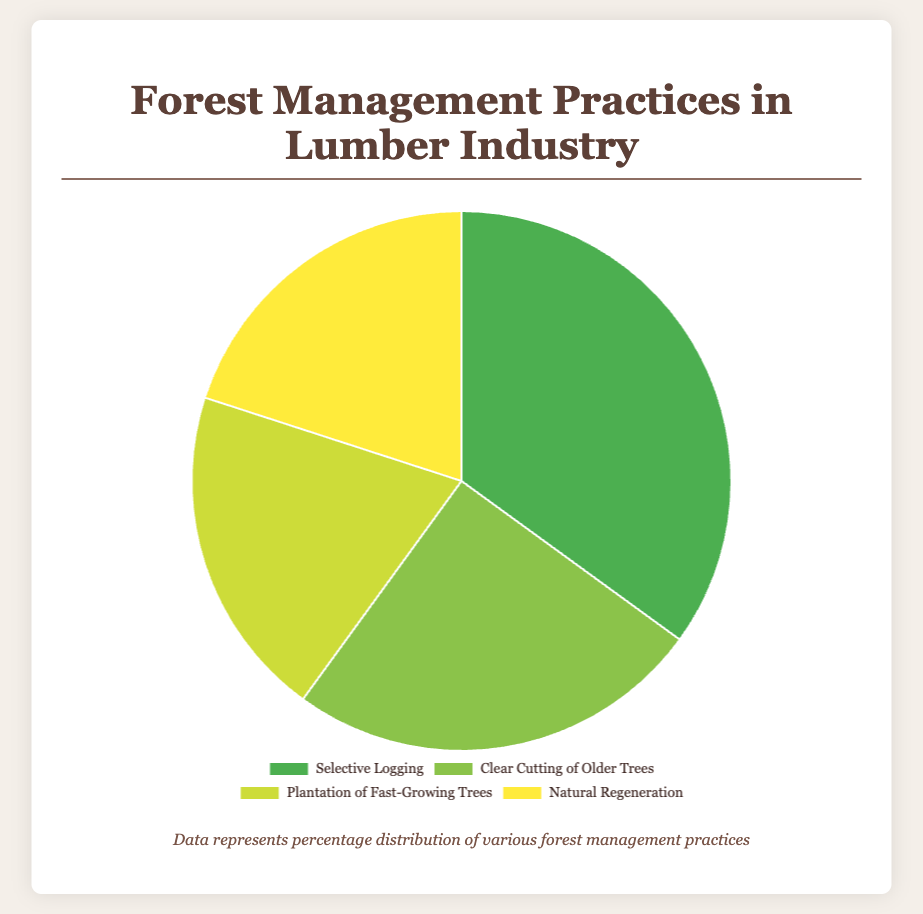Which forest management practice has the highest percentage? The pie chart shows four allocation segments, with "Selective Logging" having the largest slice, indicating the highest percentage.
Answer: Selective Logging How much larger is the percentage of Selective Logging compared to Clear Cutting of Older Trees? "Selective Logging" is at 35% while "Clear Cutting of Older Trees" is at 25%. The difference can be calculated by subtracting the latter from the former: 35% - 25% = 10%.
Answer: 10% What is the combined percentage of Plantation of Fast-Growing Trees and Natural Regeneration? According to the chart, both "Plantation of Fast-Growing Trees" and "Natural Regeneration" are at 20% each. Adding these two values gives 20% + 20% = 40%.
Answer: 40% Which two forest management practices are equal in percentage? From the pie chart, "Plantation of Fast-Growing Trees" and "Natural Regeneration" both have a share of 20%.
Answer: Plantation of Fast-Growing Trees and Natural Regeneration Compare the combined percentage of Clear Cutting of Older Trees and Natural Regeneration to the percentage of Selective Logging. Which is higher, and by how much? Adding the percentages of "Clear Cutting of Older Trees" (25%) and "Natural Regeneration" (20%) gives 45%. "Selective Logging" is at 35%. Thus, 45% - 35% = 10%, so the combined percentage is higher by 10%.
Answer: Combined of Clear Cutting and Natural Regeneration, by 10% Which practice has the smallest percentage, and what is its value? Both "Plantation of Fast-Growing Trees" and "Natural Regeneration" have the smallest percentage, each at 20%.
Answer: Plantation of Fast-Growing Trees and Natural Regeneration, 20% What proportion of the forest management practices involves the planting of new trees? Only "Plantation of Fast-Growing Trees" refers to the planting of new trees, which accounts for 20% of the total practices.
Answer: 20% If "Selective Logging" were reduced by 5%, how would its percentage compare to "Clear Cutting of Older Trees"? Reducing "Selective Logging" by 5% makes it 35% - 5% = 30%. Compared to "Clear Cutting of Older Trees" at 25%, "Selective Logging" would still be higher by 5%.
Answer: Selective Logging would still be higher by 5% 